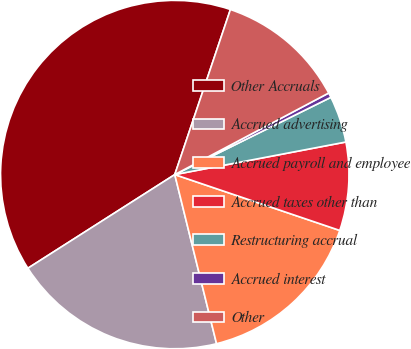Convert chart. <chart><loc_0><loc_0><loc_500><loc_500><pie_chart><fcel>Other Accruals<fcel>Accrued advertising<fcel>Accrued payroll and employee<fcel>Accrued taxes other than<fcel>Restructuring accrual<fcel>Accrued interest<fcel>Other<nl><fcel>39.21%<fcel>19.82%<fcel>15.95%<fcel>8.19%<fcel>4.32%<fcel>0.44%<fcel>12.07%<nl></chart> 